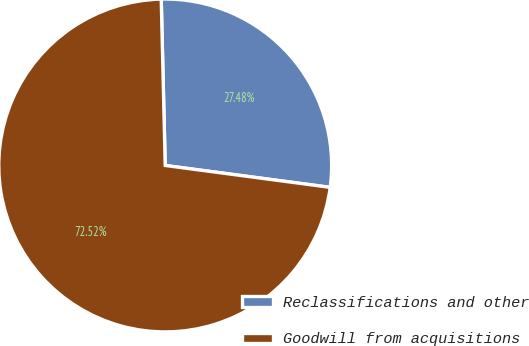<chart> <loc_0><loc_0><loc_500><loc_500><pie_chart><fcel>Reclassifications and other<fcel>Goodwill from acquisitions<nl><fcel>27.48%<fcel>72.52%<nl></chart> 